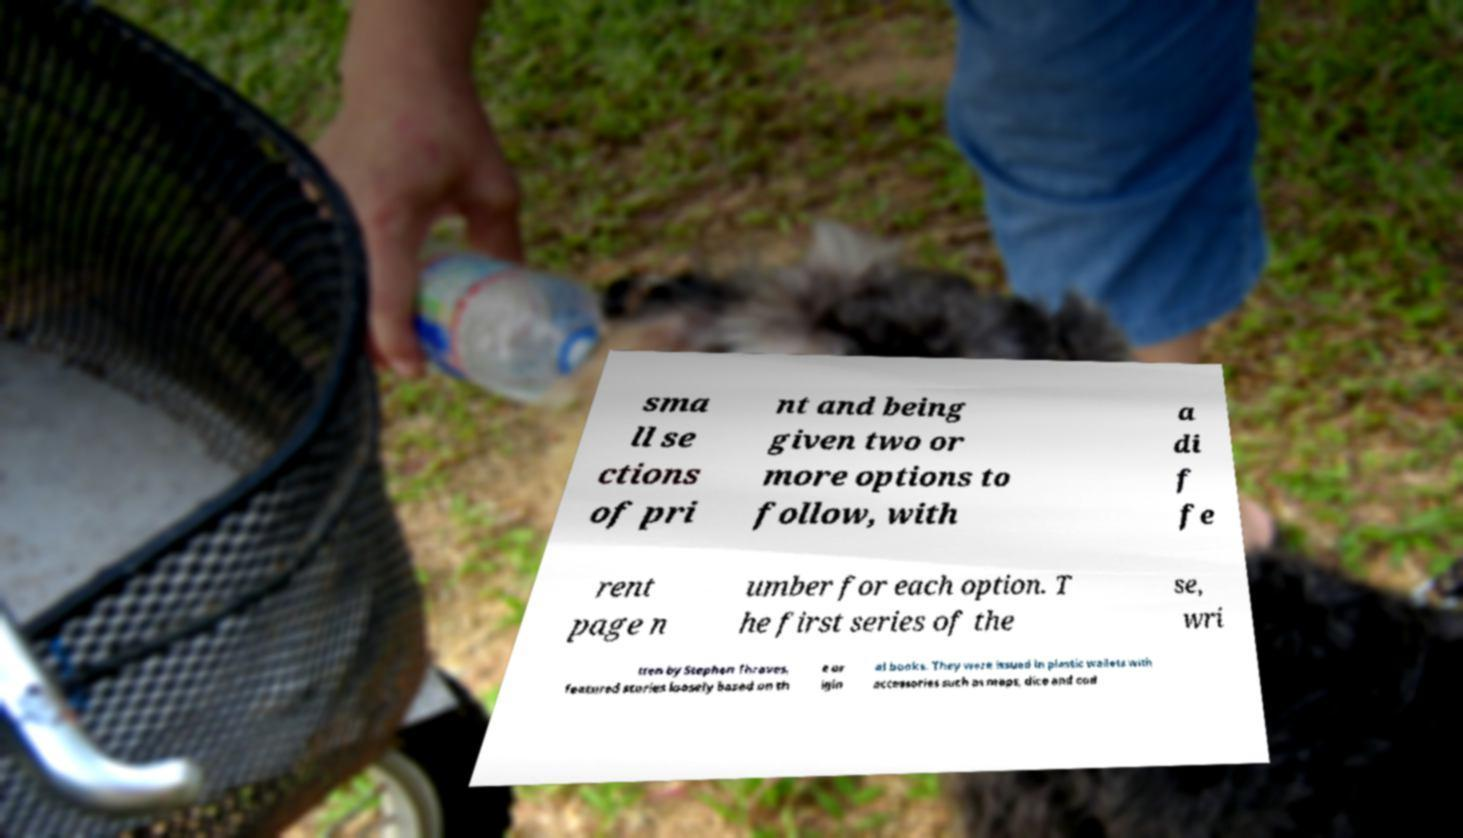What messages or text are displayed in this image? I need them in a readable, typed format. sma ll se ctions of pri nt and being given two or more options to follow, with a di f fe rent page n umber for each option. T he first series of the se, wri tten by Stephen Thraves, featured stories loosely based on th e or igin al books. They were issued in plastic wallets with accessories such as maps, dice and cod 